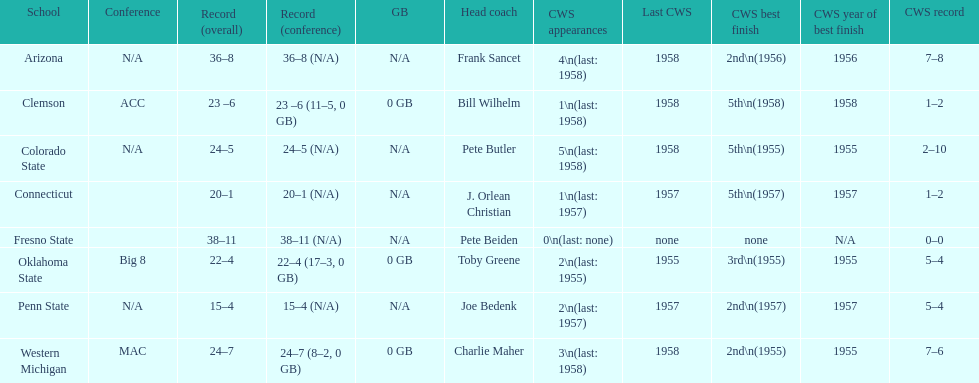Which school has no cws appearances? Fresno State. 